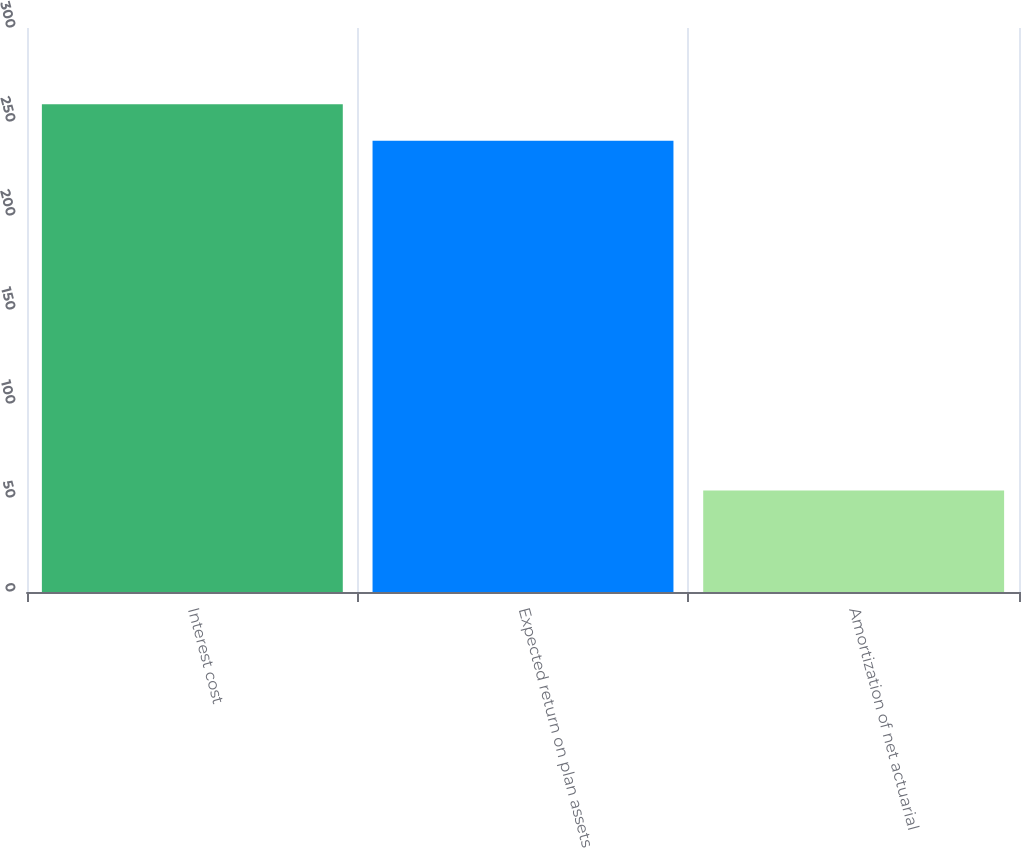Convert chart to OTSL. <chart><loc_0><loc_0><loc_500><loc_500><bar_chart><fcel>Interest cost<fcel>Expected return on plan assets<fcel>Amortization of net actuarial<nl><fcel>259.5<fcel>240<fcel>54<nl></chart> 